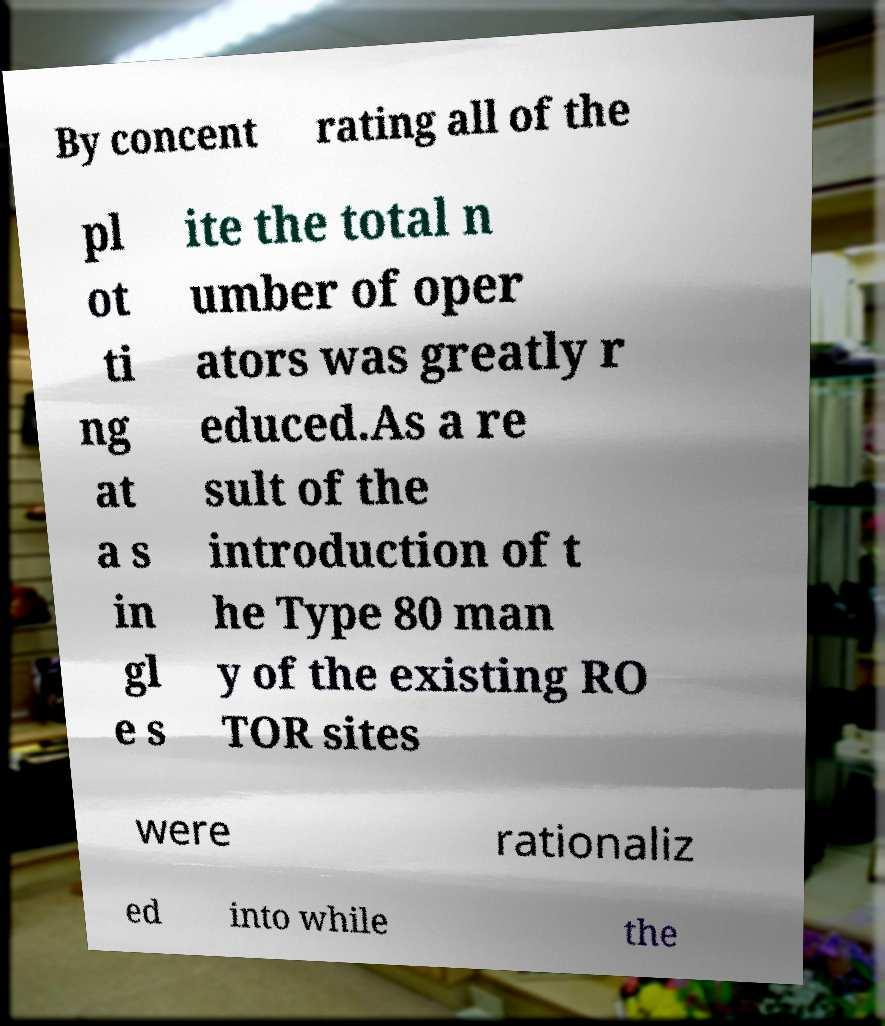Could you extract and type out the text from this image? By concent rating all of the pl ot ti ng at a s in gl e s ite the total n umber of oper ators was greatly r educed.As a re sult of the introduction of t he Type 80 man y of the existing RO TOR sites were rationaliz ed into while the 